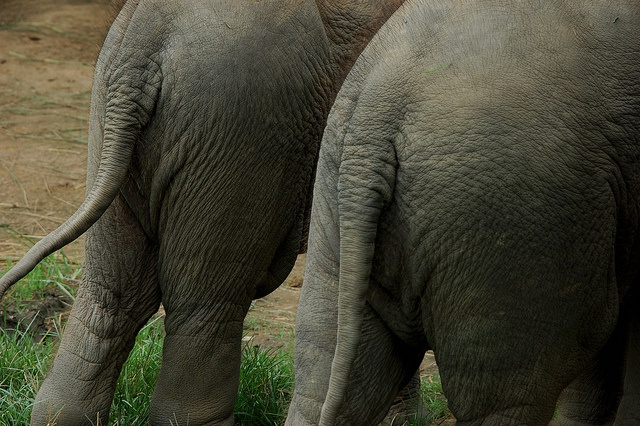Describe the objects in this image and their specific colors. I can see elephant in black and gray tones and elephant in black and gray tones in this image. 